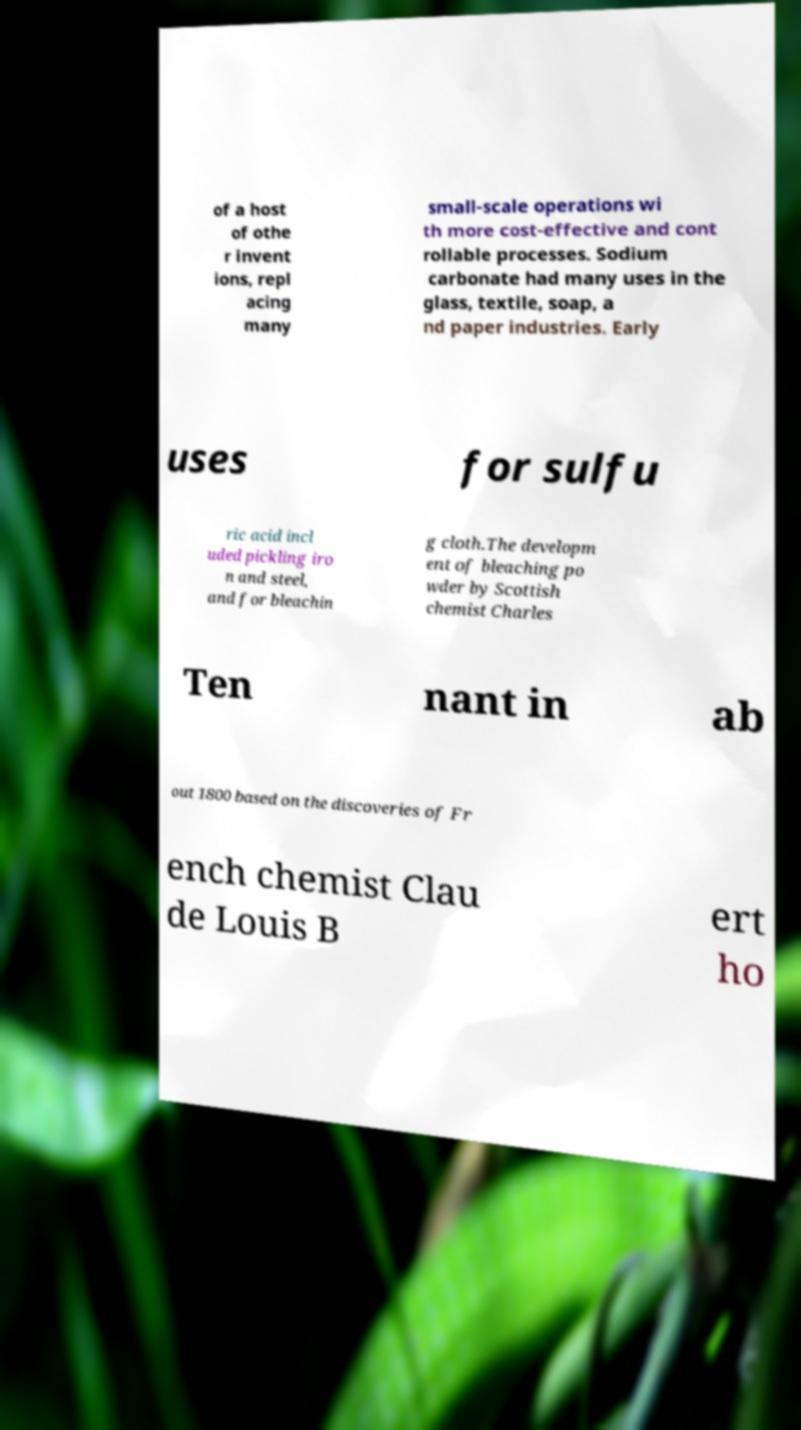I need the written content from this picture converted into text. Can you do that? of a host of othe r invent ions, repl acing many small-scale operations wi th more cost-effective and cont rollable processes. Sodium carbonate had many uses in the glass, textile, soap, a nd paper industries. Early uses for sulfu ric acid incl uded pickling iro n and steel, and for bleachin g cloth.The developm ent of bleaching po wder by Scottish chemist Charles Ten nant in ab out 1800 based on the discoveries of Fr ench chemist Clau de Louis B ert ho 